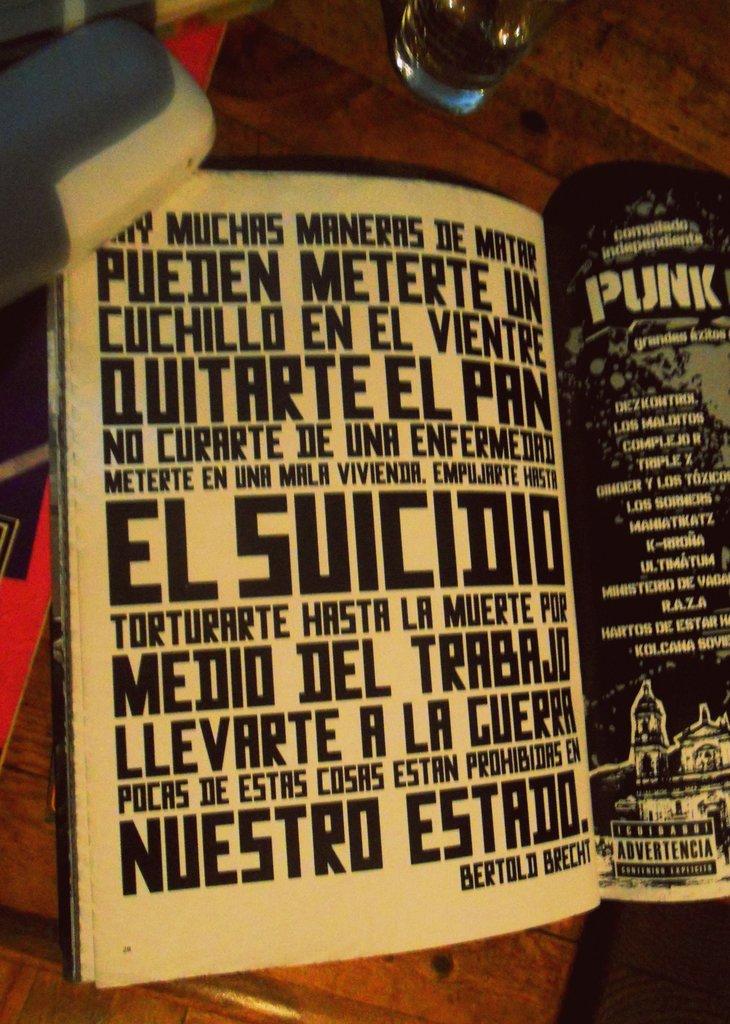What is the largest word on the black page?
Give a very brief answer. El suicidio. What is the largest words on the white page?
Your answer should be compact. El suicidio. 